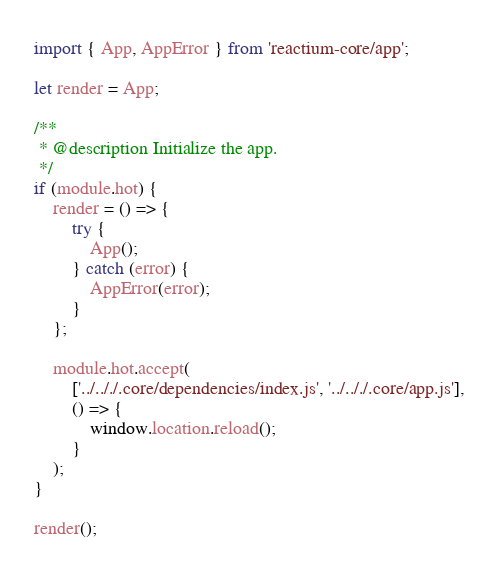<code> <loc_0><loc_0><loc_500><loc_500><_JavaScript_>import { App, AppError } from 'reactium-core/app';

let render = App;

/**
 * @description Initialize the app.
 */
if (module.hot) {
    render = () => {
        try {
            App();
        } catch (error) {
            AppError(error);
        }
    };

    module.hot.accept(
        ['../.././.core/dependencies/index.js', '../.././.core/app.js'],
        () => {
            window.location.reload();
        }
    );
}

render();
</code> 